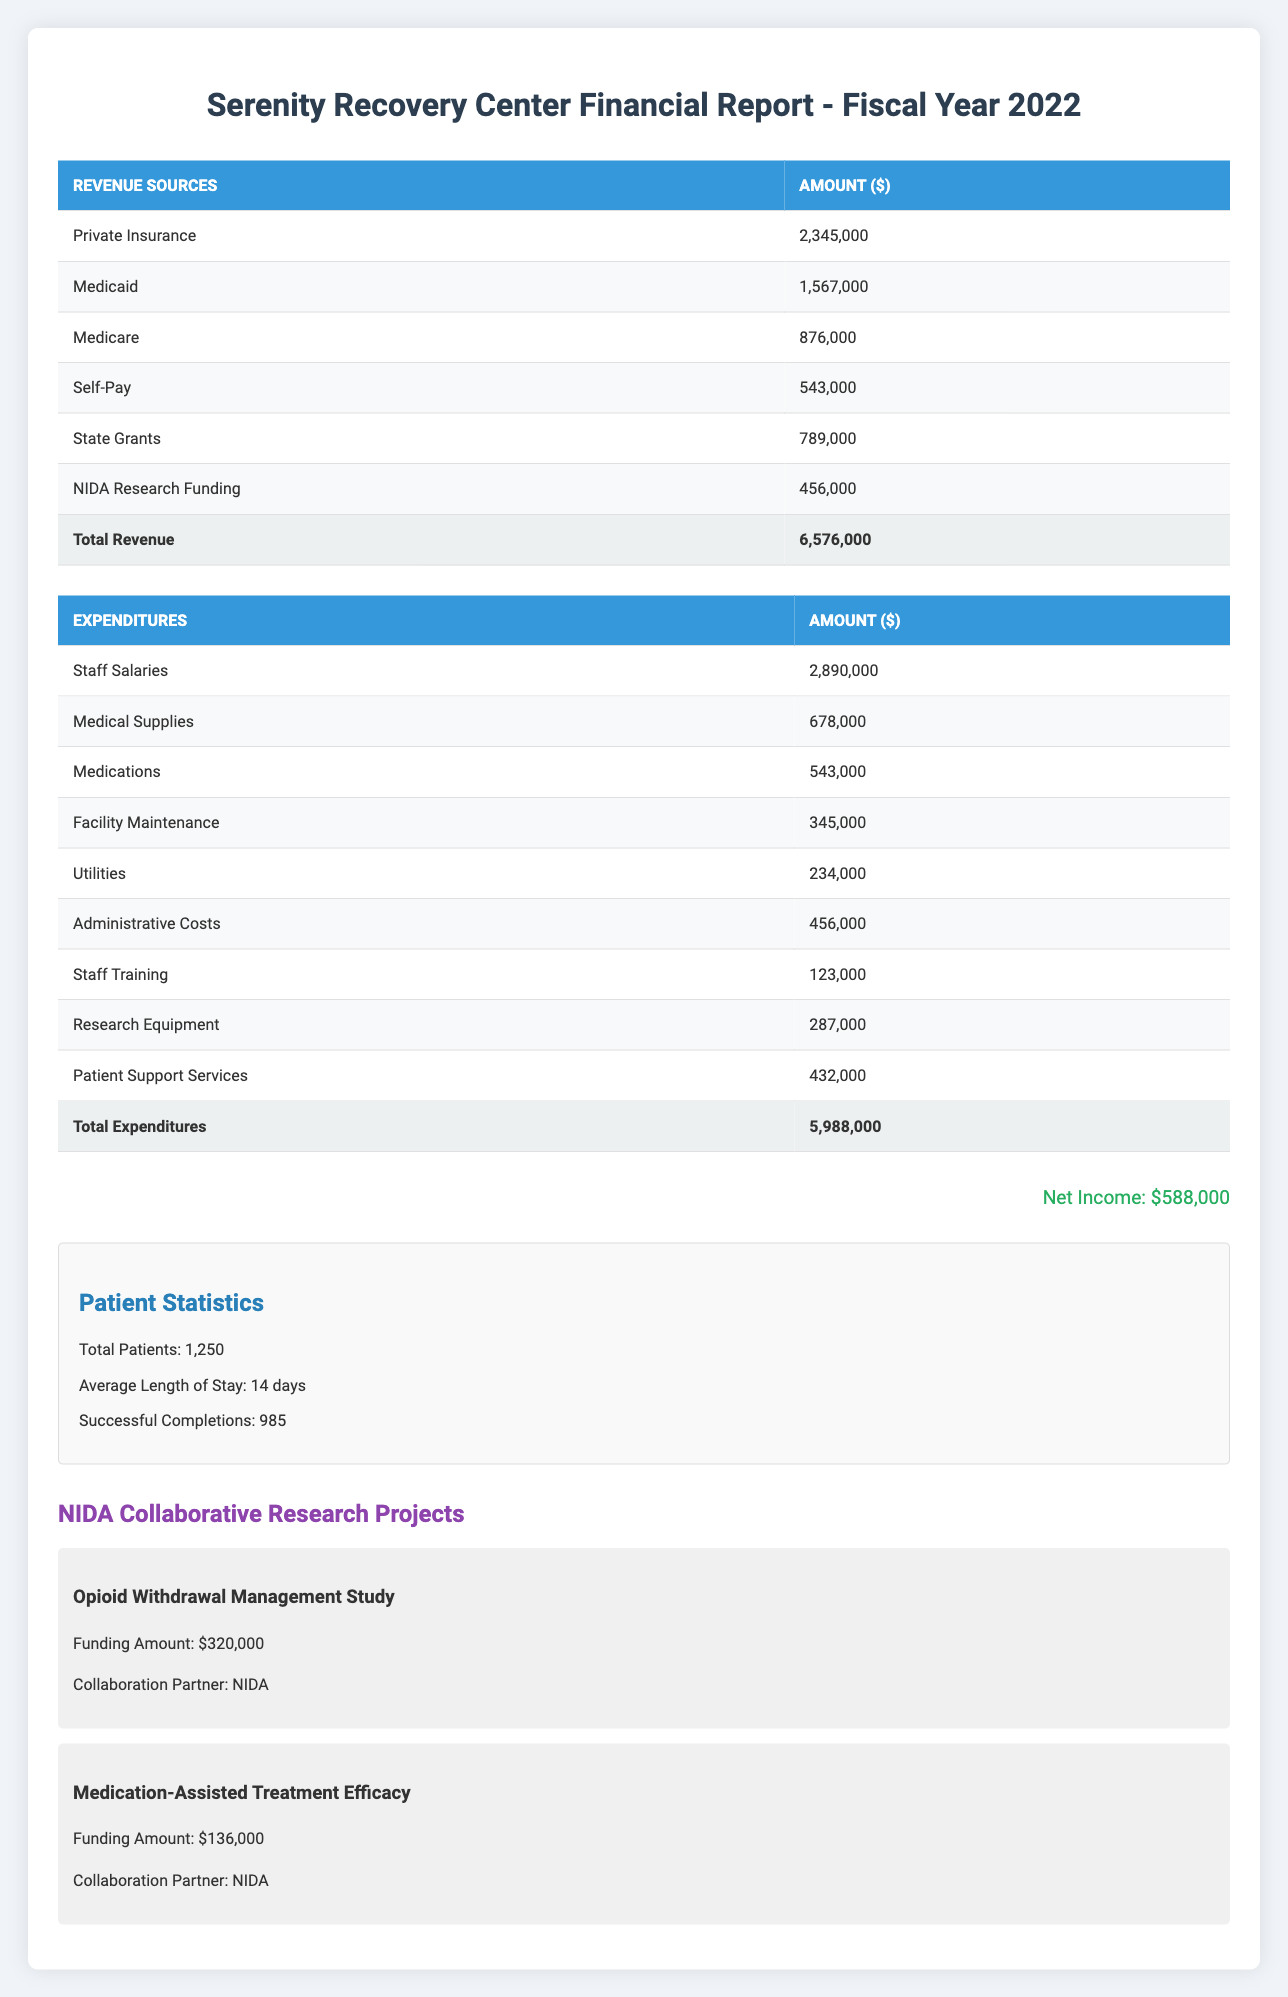What is the total revenue generated by the Serenity Recovery Center in 2022? The total revenue is listed in the table under "Total Revenue," which shows an amount of 6,576,000.
Answer: 6,576,000 What is the highest revenue source for the facility? The highest revenue source can be found by comparing the amounts in the revenue sources. Private Insurance at 2,345,000 is the highest.
Answer: Private Insurance What are the total expenditures for the facility in 2022? The total expenditures are provided in the table under "Total Expenditures" and is recorded as 5,988,000.
Answer: 5,988,000 Is the net income for the facility greater than 500,000? The net income is stated as 588,000. Since 588,000 is greater than 500,000, the statement is true.
Answer: Yes What is the difference between total revenue and total expenditures? The total revenue is 6,576,000 and total expenditures are 5,988,000. The difference is calculated as 6,576,000 - 5,988,000 = 588,000.
Answer: 588,000 What percentage of the total revenue comes from Medicaid? To find this percentage, divide Medicaid revenue (1,567,000) by total revenue (6,576,000) and multiply by 100. Thus, (1,567,000 / 6,576,000) * 100 ≈ 23.86%.
Answer: 23.86% How much was spent on Staff Salaries compared to Patient Support Services? Staff Salaries amount to 2,890,000, and Patient Support Services are at 432,000. The difference is 2,890,000 - 432,000 = 2,458,000 more was spent on Staff Salaries.
Answer: 2,458,000 Is the funding from NIDA greater than the expenditure on Medical Supplies? NIDA Research Funding is 456,000 and Medical Supplies expenditure is 678,000. Since 456,000 is not greater than 678,000, the statement is false.
Answer: No What is the average expenditure per patient for the facility? The total expenditures are 5,988,000, and the total patients are 1,250. To find the average, divide total expenditures by total patients: 5,988,000 / 1,250 = 4,790.4.
Answer: 4,790.4 